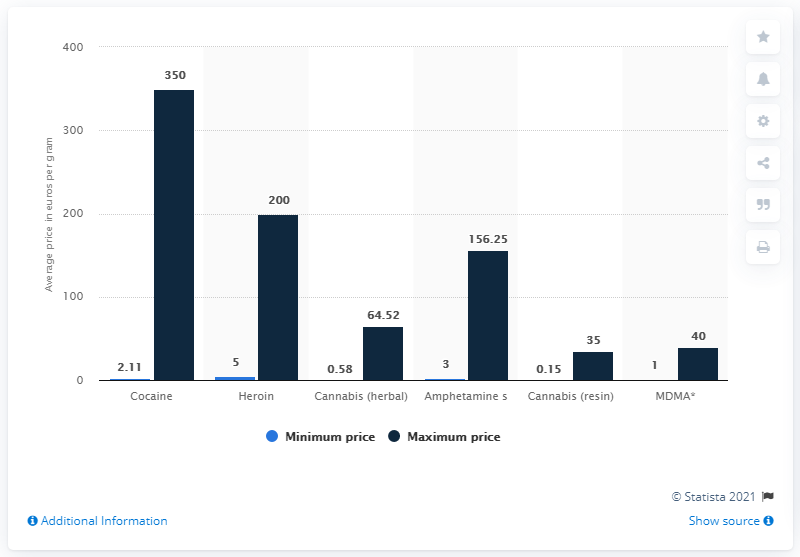What drug had the highest average price per gram among illicit drugs in Sweden in 2017?
 Cocaine 